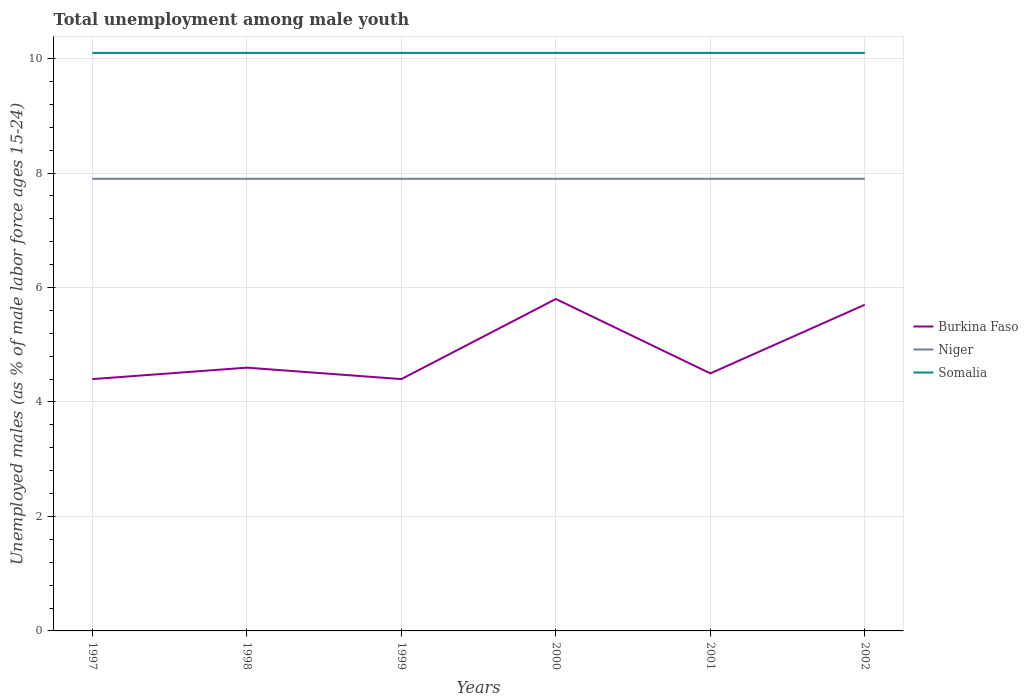How many different coloured lines are there?
Provide a short and direct response. 3. Does the line corresponding to Burkina Faso intersect with the line corresponding to Niger?
Provide a succinct answer. No. Across all years, what is the maximum percentage of unemployed males in in Burkina Faso?
Provide a short and direct response. 4.4. In which year was the percentage of unemployed males in in Burkina Faso maximum?
Your answer should be compact. 1997. What is the total percentage of unemployed males in in Niger in the graph?
Your answer should be compact. 0. Are the values on the major ticks of Y-axis written in scientific E-notation?
Offer a very short reply. No. Where does the legend appear in the graph?
Offer a terse response. Center right. How many legend labels are there?
Your answer should be very brief. 3. How are the legend labels stacked?
Provide a short and direct response. Vertical. What is the title of the graph?
Provide a short and direct response. Total unemployment among male youth. Does "Kuwait" appear as one of the legend labels in the graph?
Make the answer very short. No. What is the label or title of the Y-axis?
Your answer should be compact. Unemployed males (as % of male labor force ages 15-24). What is the Unemployed males (as % of male labor force ages 15-24) of Burkina Faso in 1997?
Your answer should be very brief. 4.4. What is the Unemployed males (as % of male labor force ages 15-24) of Niger in 1997?
Make the answer very short. 7.9. What is the Unemployed males (as % of male labor force ages 15-24) of Somalia in 1997?
Keep it short and to the point. 10.1. What is the Unemployed males (as % of male labor force ages 15-24) of Burkina Faso in 1998?
Provide a succinct answer. 4.6. What is the Unemployed males (as % of male labor force ages 15-24) in Niger in 1998?
Your answer should be compact. 7.9. What is the Unemployed males (as % of male labor force ages 15-24) of Somalia in 1998?
Give a very brief answer. 10.1. What is the Unemployed males (as % of male labor force ages 15-24) in Burkina Faso in 1999?
Provide a short and direct response. 4.4. What is the Unemployed males (as % of male labor force ages 15-24) of Niger in 1999?
Provide a short and direct response. 7.9. What is the Unemployed males (as % of male labor force ages 15-24) in Somalia in 1999?
Your answer should be very brief. 10.1. What is the Unemployed males (as % of male labor force ages 15-24) of Burkina Faso in 2000?
Offer a very short reply. 5.8. What is the Unemployed males (as % of male labor force ages 15-24) of Niger in 2000?
Your answer should be compact. 7.9. What is the Unemployed males (as % of male labor force ages 15-24) in Somalia in 2000?
Ensure brevity in your answer.  10.1. What is the Unemployed males (as % of male labor force ages 15-24) of Burkina Faso in 2001?
Ensure brevity in your answer.  4.5. What is the Unemployed males (as % of male labor force ages 15-24) of Niger in 2001?
Provide a succinct answer. 7.9. What is the Unemployed males (as % of male labor force ages 15-24) of Somalia in 2001?
Give a very brief answer. 10.1. What is the Unemployed males (as % of male labor force ages 15-24) of Burkina Faso in 2002?
Provide a succinct answer. 5.7. What is the Unemployed males (as % of male labor force ages 15-24) of Niger in 2002?
Offer a very short reply. 7.9. What is the Unemployed males (as % of male labor force ages 15-24) of Somalia in 2002?
Provide a succinct answer. 10.1. Across all years, what is the maximum Unemployed males (as % of male labor force ages 15-24) of Burkina Faso?
Provide a succinct answer. 5.8. Across all years, what is the maximum Unemployed males (as % of male labor force ages 15-24) in Niger?
Offer a terse response. 7.9. Across all years, what is the maximum Unemployed males (as % of male labor force ages 15-24) of Somalia?
Ensure brevity in your answer.  10.1. Across all years, what is the minimum Unemployed males (as % of male labor force ages 15-24) of Burkina Faso?
Make the answer very short. 4.4. Across all years, what is the minimum Unemployed males (as % of male labor force ages 15-24) of Niger?
Ensure brevity in your answer.  7.9. Across all years, what is the minimum Unemployed males (as % of male labor force ages 15-24) in Somalia?
Offer a very short reply. 10.1. What is the total Unemployed males (as % of male labor force ages 15-24) of Burkina Faso in the graph?
Offer a very short reply. 29.4. What is the total Unemployed males (as % of male labor force ages 15-24) in Niger in the graph?
Your response must be concise. 47.4. What is the total Unemployed males (as % of male labor force ages 15-24) in Somalia in the graph?
Offer a very short reply. 60.6. What is the difference between the Unemployed males (as % of male labor force ages 15-24) in Niger in 1997 and that in 1998?
Offer a very short reply. 0. What is the difference between the Unemployed males (as % of male labor force ages 15-24) in Somalia in 1997 and that in 1998?
Ensure brevity in your answer.  0. What is the difference between the Unemployed males (as % of male labor force ages 15-24) in Burkina Faso in 1997 and that in 1999?
Offer a terse response. 0. What is the difference between the Unemployed males (as % of male labor force ages 15-24) in Niger in 1997 and that in 1999?
Give a very brief answer. 0. What is the difference between the Unemployed males (as % of male labor force ages 15-24) of Burkina Faso in 1997 and that in 2000?
Offer a terse response. -1.4. What is the difference between the Unemployed males (as % of male labor force ages 15-24) of Somalia in 1997 and that in 2000?
Provide a succinct answer. 0. What is the difference between the Unemployed males (as % of male labor force ages 15-24) of Burkina Faso in 1997 and that in 2001?
Offer a very short reply. -0.1. What is the difference between the Unemployed males (as % of male labor force ages 15-24) in Niger in 1997 and that in 2002?
Offer a terse response. 0. What is the difference between the Unemployed males (as % of male labor force ages 15-24) of Somalia in 1997 and that in 2002?
Give a very brief answer. 0. What is the difference between the Unemployed males (as % of male labor force ages 15-24) in Niger in 1998 and that in 1999?
Make the answer very short. 0. What is the difference between the Unemployed males (as % of male labor force ages 15-24) in Somalia in 1998 and that in 1999?
Your answer should be compact. 0. What is the difference between the Unemployed males (as % of male labor force ages 15-24) of Somalia in 1998 and that in 2001?
Provide a short and direct response. 0. What is the difference between the Unemployed males (as % of male labor force ages 15-24) in Burkina Faso in 1998 and that in 2002?
Provide a short and direct response. -1.1. What is the difference between the Unemployed males (as % of male labor force ages 15-24) of Niger in 1998 and that in 2002?
Make the answer very short. 0. What is the difference between the Unemployed males (as % of male labor force ages 15-24) of Burkina Faso in 1999 and that in 2000?
Provide a succinct answer. -1.4. What is the difference between the Unemployed males (as % of male labor force ages 15-24) in Niger in 1999 and that in 2000?
Your response must be concise. 0. What is the difference between the Unemployed males (as % of male labor force ages 15-24) of Somalia in 1999 and that in 2000?
Your response must be concise. 0. What is the difference between the Unemployed males (as % of male labor force ages 15-24) in Somalia in 1999 and that in 2002?
Keep it short and to the point. 0. What is the difference between the Unemployed males (as % of male labor force ages 15-24) in Niger in 2000 and that in 2002?
Your answer should be compact. 0. What is the difference between the Unemployed males (as % of male labor force ages 15-24) of Somalia in 2001 and that in 2002?
Give a very brief answer. 0. What is the difference between the Unemployed males (as % of male labor force ages 15-24) in Burkina Faso in 1997 and the Unemployed males (as % of male labor force ages 15-24) in Niger in 1998?
Provide a succinct answer. -3.5. What is the difference between the Unemployed males (as % of male labor force ages 15-24) in Niger in 1997 and the Unemployed males (as % of male labor force ages 15-24) in Somalia in 1998?
Make the answer very short. -2.2. What is the difference between the Unemployed males (as % of male labor force ages 15-24) in Burkina Faso in 1997 and the Unemployed males (as % of male labor force ages 15-24) in Niger in 2000?
Ensure brevity in your answer.  -3.5. What is the difference between the Unemployed males (as % of male labor force ages 15-24) of Burkina Faso in 1997 and the Unemployed males (as % of male labor force ages 15-24) of Niger in 2001?
Your answer should be very brief. -3.5. What is the difference between the Unemployed males (as % of male labor force ages 15-24) in Burkina Faso in 1997 and the Unemployed males (as % of male labor force ages 15-24) in Somalia in 2001?
Ensure brevity in your answer.  -5.7. What is the difference between the Unemployed males (as % of male labor force ages 15-24) in Burkina Faso in 1997 and the Unemployed males (as % of male labor force ages 15-24) in Somalia in 2002?
Give a very brief answer. -5.7. What is the difference between the Unemployed males (as % of male labor force ages 15-24) of Niger in 1997 and the Unemployed males (as % of male labor force ages 15-24) of Somalia in 2002?
Make the answer very short. -2.2. What is the difference between the Unemployed males (as % of male labor force ages 15-24) in Niger in 1998 and the Unemployed males (as % of male labor force ages 15-24) in Somalia in 2000?
Offer a terse response. -2.2. What is the difference between the Unemployed males (as % of male labor force ages 15-24) in Burkina Faso in 1998 and the Unemployed males (as % of male labor force ages 15-24) in Somalia in 2001?
Keep it short and to the point. -5.5. What is the difference between the Unemployed males (as % of male labor force ages 15-24) in Niger in 1998 and the Unemployed males (as % of male labor force ages 15-24) in Somalia in 2001?
Offer a terse response. -2.2. What is the difference between the Unemployed males (as % of male labor force ages 15-24) of Burkina Faso in 1998 and the Unemployed males (as % of male labor force ages 15-24) of Niger in 2002?
Your answer should be very brief. -3.3. What is the difference between the Unemployed males (as % of male labor force ages 15-24) of Burkina Faso in 1999 and the Unemployed males (as % of male labor force ages 15-24) of Niger in 2000?
Provide a short and direct response. -3.5. What is the difference between the Unemployed males (as % of male labor force ages 15-24) of Niger in 1999 and the Unemployed males (as % of male labor force ages 15-24) of Somalia in 2000?
Keep it short and to the point. -2.2. What is the difference between the Unemployed males (as % of male labor force ages 15-24) in Burkina Faso in 1999 and the Unemployed males (as % of male labor force ages 15-24) in Niger in 2001?
Keep it short and to the point. -3.5. What is the difference between the Unemployed males (as % of male labor force ages 15-24) of Burkina Faso in 2000 and the Unemployed males (as % of male labor force ages 15-24) of Niger in 2001?
Your answer should be very brief. -2.1. What is the difference between the Unemployed males (as % of male labor force ages 15-24) of Burkina Faso in 2000 and the Unemployed males (as % of male labor force ages 15-24) of Somalia in 2002?
Offer a terse response. -4.3. What is the difference between the Unemployed males (as % of male labor force ages 15-24) in Burkina Faso in 2001 and the Unemployed males (as % of male labor force ages 15-24) in Niger in 2002?
Your response must be concise. -3.4. What is the difference between the Unemployed males (as % of male labor force ages 15-24) in Niger in 2001 and the Unemployed males (as % of male labor force ages 15-24) in Somalia in 2002?
Keep it short and to the point. -2.2. What is the average Unemployed males (as % of male labor force ages 15-24) of Burkina Faso per year?
Provide a short and direct response. 4.9. In the year 1997, what is the difference between the Unemployed males (as % of male labor force ages 15-24) in Burkina Faso and Unemployed males (as % of male labor force ages 15-24) in Niger?
Provide a short and direct response. -3.5. In the year 1997, what is the difference between the Unemployed males (as % of male labor force ages 15-24) in Burkina Faso and Unemployed males (as % of male labor force ages 15-24) in Somalia?
Provide a short and direct response. -5.7. In the year 2000, what is the difference between the Unemployed males (as % of male labor force ages 15-24) of Burkina Faso and Unemployed males (as % of male labor force ages 15-24) of Somalia?
Offer a terse response. -4.3. In the year 2000, what is the difference between the Unemployed males (as % of male labor force ages 15-24) of Niger and Unemployed males (as % of male labor force ages 15-24) of Somalia?
Your answer should be compact. -2.2. In the year 2001, what is the difference between the Unemployed males (as % of male labor force ages 15-24) in Burkina Faso and Unemployed males (as % of male labor force ages 15-24) in Niger?
Your answer should be compact. -3.4. In the year 2001, what is the difference between the Unemployed males (as % of male labor force ages 15-24) in Burkina Faso and Unemployed males (as % of male labor force ages 15-24) in Somalia?
Your answer should be very brief. -5.6. In the year 2001, what is the difference between the Unemployed males (as % of male labor force ages 15-24) of Niger and Unemployed males (as % of male labor force ages 15-24) of Somalia?
Provide a short and direct response. -2.2. In the year 2002, what is the difference between the Unemployed males (as % of male labor force ages 15-24) in Niger and Unemployed males (as % of male labor force ages 15-24) in Somalia?
Make the answer very short. -2.2. What is the ratio of the Unemployed males (as % of male labor force ages 15-24) in Burkina Faso in 1997 to that in 1998?
Ensure brevity in your answer.  0.96. What is the ratio of the Unemployed males (as % of male labor force ages 15-24) in Niger in 1997 to that in 1998?
Offer a very short reply. 1. What is the ratio of the Unemployed males (as % of male labor force ages 15-24) of Somalia in 1997 to that in 1998?
Ensure brevity in your answer.  1. What is the ratio of the Unemployed males (as % of male labor force ages 15-24) in Niger in 1997 to that in 1999?
Keep it short and to the point. 1. What is the ratio of the Unemployed males (as % of male labor force ages 15-24) of Burkina Faso in 1997 to that in 2000?
Your answer should be compact. 0.76. What is the ratio of the Unemployed males (as % of male labor force ages 15-24) of Niger in 1997 to that in 2000?
Give a very brief answer. 1. What is the ratio of the Unemployed males (as % of male labor force ages 15-24) of Somalia in 1997 to that in 2000?
Offer a very short reply. 1. What is the ratio of the Unemployed males (as % of male labor force ages 15-24) of Burkina Faso in 1997 to that in 2001?
Provide a succinct answer. 0.98. What is the ratio of the Unemployed males (as % of male labor force ages 15-24) of Burkina Faso in 1997 to that in 2002?
Your answer should be compact. 0.77. What is the ratio of the Unemployed males (as % of male labor force ages 15-24) of Burkina Faso in 1998 to that in 1999?
Your answer should be compact. 1.05. What is the ratio of the Unemployed males (as % of male labor force ages 15-24) in Niger in 1998 to that in 1999?
Give a very brief answer. 1. What is the ratio of the Unemployed males (as % of male labor force ages 15-24) in Burkina Faso in 1998 to that in 2000?
Give a very brief answer. 0.79. What is the ratio of the Unemployed males (as % of male labor force ages 15-24) in Somalia in 1998 to that in 2000?
Offer a terse response. 1. What is the ratio of the Unemployed males (as % of male labor force ages 15-24) in Burkina Faso in 1998 to that in 2001?
Ensure brevity in your answer.  1.02. What is the ratio of the Unemployed males (as % of male labor force ages 15-24) in Niger in 1998 to that in 2001?
Offer a terse response. 1. What is the ratio of the Unemployed males (as % of male labor force ages 15-24) in Burkina Faso in 1998 to that in 2002?
Keep it short and to the point. 0.81. What is the ratio of the Unemployed males (as % of male labor force ages 15-24) of Niger in 1998 to that in 2002?
Your answer should be compact. 1. What is the ratio of the Unemployed males (as % of male labor force ages 15-24) of Burkina Faso in 1999 to that in 2000?
Make the answer very short. 0.76. What is the ratio of the Unemployed males (as % of male labor force ages 15-24) in Niger in 1999 to that in 2000?
Your response must be concise. 1. What is the ratio of the Unemployed males (as % of male labor force ages 15-24) of Burkina Faso in 1999 to that in 2001?
Your answer should be compact. 0.98. What is the ratio of the Unemployed males (as % of male labor force ages 15-24) in Somalia in 1999 to that in 2001?
Keep it short and to the point. 1. What is the ratio of the Unemployed males (as % of male labor force ages 15-24) in Burkina Faso in 1999 to that in 2002?
Your response must be concise. 0.77. What is the ratio of the Unemployed males (as % of male labor force ages 15-24) of Burkina Faso in 2000 to that in 2001?
Your answer should be very brief. 1.29. What is the ratio of the Unemployed males (as % of male labor force ages 15-24) in Niger in 2000 to that in 2001?
Make the answer very short. 1. What is the ratio of the Unemployed males (as % of male labor force ages 15-24) in Burkina Faso in 2000 to that in 2002?
Your answer should be very brief. 1.02. What is the ratio of the Unemployed males (as % of male labor force ages 15-24) of Niger in 2000 to that in 2002?
Give a very brief answer. 1. What is the ratio of the Unemployed males (as % of male labor force ages 15-24) in Burkina Faso in 2001 to that in 2002?
Your response must be concise. 0.79. What is the difference between the highest and the second highest Unemployed males (as % of male labor force ages 15-24) of Niger?
Your answer should be compact. 0. What is the difference between the highest and the second highest Unemployed males (as % of male labor force ages 15-24) in Somalia?
Your answer should be compact. 0. 